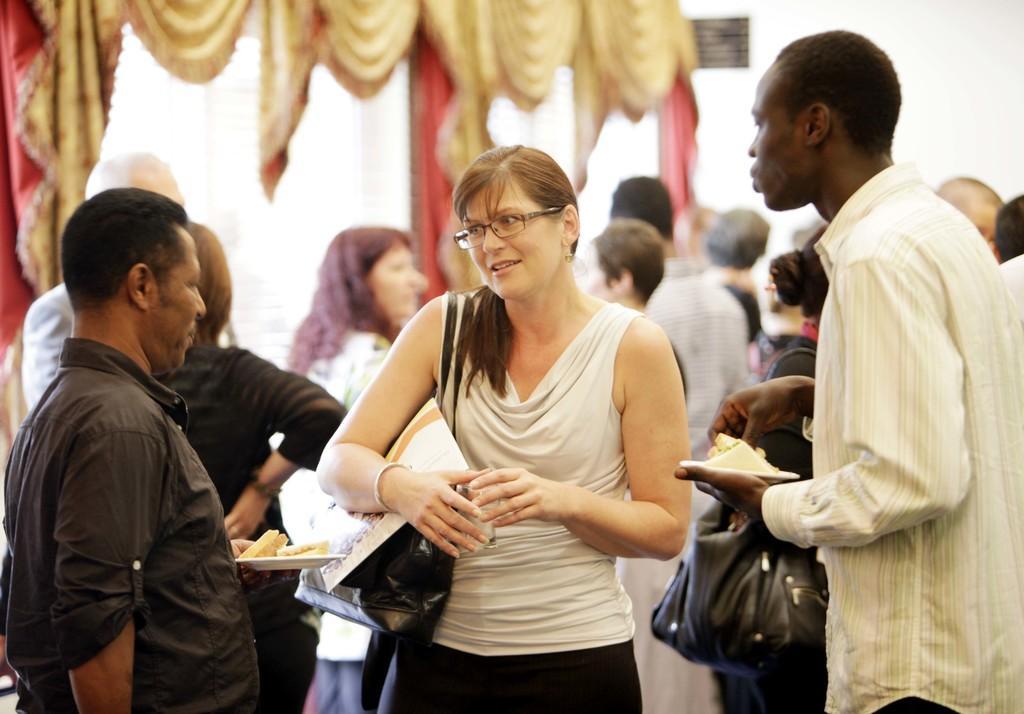Please provide a concise description of this image. This image is taken indoors. In the background there is a wall with a window and there are a few curtains. A few people are standing on the floor. On the left side of the image a man is standing and he is holding a plate with a few food items in his hands. In the middle of the image a woman is standing and she is holding a glass in her hands and she has worn a hand bag. On the right side of the image a man is standing and he is holding a plate with a food item in his hands. 